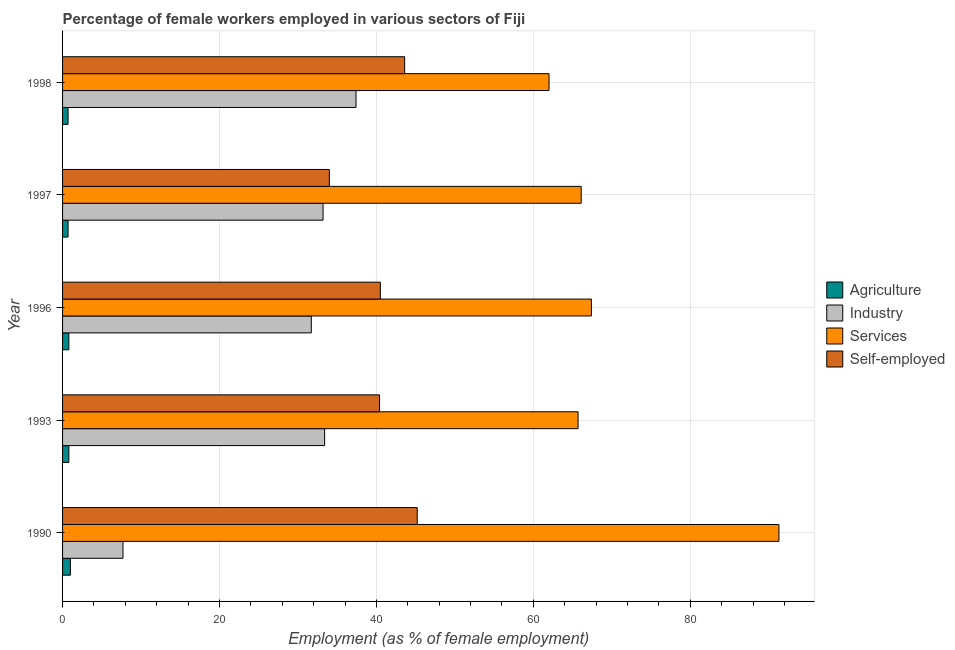How many groups of bars are there?
Make the answer very short. 5. What is the label of the 5th group of bars from the top?
Ensure brevity in your answer.  1990. In how many cases, is the number of bars for a given year not equal to the number of legend labels?
Provide a short and direct response. 0. Across all years, what is the maximum percentage of female workers in services?
Ensure brevity in your answer.  91.3. In which year was the percentage of female workers in agriculture maximum?
Provide a short and direct response. 1990. What is the total percentage of self employed female workers in the graph?
Keep it short and to the point. 203.7. What is the difference between the percentage of female workers in industry in 1990 and that in 1993?
Your answer should be very brief. -25.7. What is the difference between the percentage of self employed female workers in 1990 and the percentage of female workers in services in 1998?
Offer a terse response. -16.8. In the year 1990, what is the difference between the percentage of female workers in industry and percentage of female workers in services?
Keep it short and to the point. -83.6. What is the difference between the highest and the second highest percentage of female workers in industry?
Your response must be concise. 4. What is the difference between the highest and the lowest percentage of female workers in services?
Provide a succinct answer. 29.3. Is it the case that in every year, the sum of the percentage of female workers in services and percentage of self employed female workers is greater than the sum of percentage of female workers in industry and percentage of female workers in agriculture?
Give a very brief answer. Yes. What does the 1st bar from the top in 1990 represents?
Offer a very short reply. Self-employed. What does the 2nd bar from the bottom in 1993 represents?
Keep it short and to the point. Industry. How many bars are there?
Your answer should be compact. 20. How many years are there in the graph?
Provide a succinct answer. 5. Are the values on the major ticks of X-axis written in scientific E-notation?
Keep it short and to the point. No. Where does the legend appear in the graph?
Offer a terse response. Center right. How many legend labels are there?
Offer a terse response. 4. What is the title of the graph?
Provide a short and direct response. Percentage of female workers employed in various sectors of Fiji. Does "Labor Taxes" appear as one of the legend labels in the graph?
Your response must be concise. No. What is the label or title of the X-axis?
Your answer should be compact. Employment (as % of female employment). What is the Employment (as % of female employment) in Industry in 1990?
Offer a very short reply. 7.7. What is the Employment (as % of female employment) of Services in 1990?
Offer a very short reply. 91.3. What is the Employment (as % of female employment) of Self-employed in 1990?
Keep it short and to the point. 45.2. What is the Employment (as % of female employment) in Agriculture in 1993?
Keep it short and to the point. 0.8. What is the Employment (as % of female employment) of Industry in 1993?
Your answer should be compact. 33.4. What is the Employment (as % of female employment) in Services in 1993?
Make the answer very short. 65.7. What is the Employment (as % of female employment) in Self-employed in 1993?
Your answer should be compact. 40.4. What is the Employment (as % of female employment) in Agriculture in 1996?
Your response must be concise. 0.8. What is the Employment (as % of female employment) of Industry in 1996?
Your answer should be compact. 31.7. What is the Employment (as % of female employment) of Services in 1996?
Your answer should be compact. 67.4. What is the Employment (as % of female employment) of Self-employed in 1996?
Your answer should be compact. 40.5. What is the Employment (as % of female employment) in Agriculture in 1997?
Make the answer very short. 0.7. What is the Employment (as % of female employment) in Industry in 1997?
Your response must be concise. 33.2. What is the Employment (as % of female employment) in Services in 1997?
Offer a terse response. 66.1. What is the Employment (as % of female employment) of Agriculture in 1998?
Provide a succinct answer. 0.7. What is the Employment (as % of female employment) of Industry in 1998?
Ensure brevity in your answer.  37.4. What is the Employment (as % of female employment) in Self-employed in 1998?
Provide a short and direct response. 43.6. Across all years, what is the maximum Employment (as % of female employment) in Agriculture?
Ensure brevity in your answer.  1. Across all years, what is the maximum Employment (as % of female employment) of Industry?
Give a very brief answer. 37.4. Across all years, what is the maximum Employment (as % of female employment) in Services?
Your answer should be very brief. 91.3. Across all years, what is the maximum Employment (as % of female employment) in Self-employed?
Your answer should be very brief. 45.2. Across all years, what is the minimum Employment (as % of female employment) of Agriculture?
Keep it short and to the point. 0.7. Across all years, what is the minimum Employment (as % of female employment) of Industry?
Offer a very short reply. 7.7. What is the total Employment (as % of female employment) of Industry in the graph?
Give a very brief answer. 143.4. What is the total Employment (as % of female employment) in Services in the graph?
Your response must be concise. 352.5. What is the total Employment (as % of female employment) of Self-employed in the graph?
Give a very brief answer. 203.7. What is the difference between the Employment (as % of female employment) of Agriculture in 1990 and that in 1993?
Provide a succinct answer. 0.2. What is the difference between the Employment (as % of female employment) in Industry in 1990 and that in 1993?
Keep it short and to the point. -25.7. What is the difference between the Employment (as % of female employment) of Services in 1990 and that in 1993?
Offer a terse response. 25.6. What is the difference between the Employment (as % of female employment) of Self-employed in 1990 and that in 1993?
Your answer should be very brief. 4.8. What is the difference between the Employment (as % of female employment) in Agriculture in 1990 and that in 1996?
Give a very brief answer. 0.2. What is the difference between the Employment (as % of female employment) of Industry in 1990 and that in 1996?
Your response must be concise. -24. What is the difference between the Employment (as % of female employment) in Services in 1990 and that in 1996?
Your response must be concise. 23.9. What is the difference between the Employment (as % of female employment) in Agriculture in 1990 and that in 1997?
Make the answer very short. 0.3. What is the difference between the Employment (as % of female employment) of Industry in 1990 and that in 1997?
Provide a succinct answer. -25.5. What is the difference between the Employment (as % of female employment) in Services in 1990 and that in 1997?
Give a very brief answer. 25.2. What is the difference between the Employment (as % of female employment) of Industry in 1990 and that in 1998?
Make the answer very short. -29.7. What is the difference between the Employment (as % of female employment) of Services in 1990 and that in 1998?
Ensure brevity in your answer.  29.3. What is the difference between the Employment (as % of female employment) in Self-employed in 1990 and that in 1998?
Your response must be concise. 1.6. What is the difference between the Employment (as % of female employment) of Industry in 1993 and that in 1996?
Your answer should be very brief. 1.7. What is the difference between the Employment (as % of female employment) in Services in 1993 and that in 1996?
Your response must be concise. -1.7. What is the difference between the Employment (as % of female employment) in Self-employed in 1993 and that in 1997?
Make the answer very short. 6.4. What is the difference between the Employment (as % of female employment) of Agriculture in 1993 and that in 1998?
Keep it short and to the point. 0.1. What is the difference between the Employment (as % of female employment) of Industry in 1993 and that in 1998?
Keep it short and to the point. -4. What is the difference between the Employment (as % of female employment) in Industry in 1996 and that in 1997?
Offer a terse response. -1.5. What is the difference between the Employment (as % of female employment) in Self-employed in 1996 and that in 1997?
Your answer should be compact. 6.5. What is the difference between the Employment (as % of female employment) in Agriculture in 1996 and that in 1998?
Your response must be concise. 0.1. What is the difference between the Employment (as % of female employment) in Industry in 1996 and that in 1998?
Provide a succinct answer. -5.7. What is the difference between the Employment (as % of female employment) in Services in 1996 and that in 1998?
Ensure brevity in your answer.  5.4. What is the difference between the Employment (as % of female employment) of Agriculture in 1997 and that in 1998?
Ensure brevity in your answer.  0. What is the difference between the Employment (as % of female employment) of Agriculture in 1990 and the Employment (as % of female employment) of Industry in 1993?
Make the answer very short. -32.4. What is the difference between the Employment (as % of female employment) in Agriculture in 1990 and the Employment (as % of female employment) in Services in 1993?
Your answer should be very brief. -64.7. What is the difference between the Employment (as % of female employment) in Agriculture in 1990 and the Employment (as % of female employment) in Self-employed in 1993?
Provide a succinct answer. -39.4. What is the difference between the Employment (as % of female employment) of Industry in 1990 and the Employment (as % of female employment) of Services in 1993?
Keep it short and to the point. -58. What is the difference between the Employment (as % of female employment) of Industry in 1990 and the Employment (as % of female employment) of Self-employed in 1993?
Provide a short and direct response. -32.7. What is the difference between the Employment (as % of female employment) of Services in 1990 and the Employment (as % of female employment) of Self-employed in 1993?
Ensure brevity in your answer.  50.9. What is the difference between the Employment (as % of female employment) in Agriculture in 1990 and the Employment (as % of female employment) in Industry in 1996?
Ensure brevity in your answer.  -30.7. What is the difference between the Employment (as % of female employment) in Agriculture in 1990 and the Employment (as % of female employment) in Services in 1996?
Offer a terse response. -66.4. What is the difference between the Employment (as % of female employment) in Agriculture in 1990 and the Employment (as % of female employment) in Self-employed in 1996?
Provide a succinct answer. -39.5. What is the difference between the Employment (as % of female employment) of Industry in 1990 and the Employment (as % of female employment) of Services in 1996?
Offer a terse response. -59.7. What is the difference between the Employment (as % of female employment) in Industry in 1990 and the Employment (as % of female employment) in Self-employed in 1996?
Your answer should be very brief. -32.8. What is the difference between the Employment (as % of female employment) in Services in 1990 and the Employment (as % of female employment) in Self-employed in 1996?
Provide a short and direct response. 50.8. What is the difference between the Employment (as % of female employment) of Agriculture in 1990 and the Employment (as % of female employment) of Industry in 1997?
Keep it short and to the point. -32.2. What is the difference between the Employment (as % of female employment) of Agriculture in 1990 and the Employment (as % of female employment) of Services in 1997?
Your answer should be compact. -65.1. What is the difference between the Employment (as % of female employment) of Agriculture in 1990 and the Employment (as % of female employment) of Self-employed in 1997?
Offer a terse response. -33. What is the difference between the Employment (as % of female employment) in Industry in 1990 and the Employment (as % of female employment) in Services in 1997?
Your response must be concise. -58.4. What is the difference between the Employment (as % of female employment) in Industry in 1990 and the Employment (as % of female employment) in Self-employed in 1997?
Your answer should be compact. -26.3. What is the difference between the Employment (as % of female employment) in Services in 1990 and the Employment (as % of female employment) in Self-employed in 1997?
Your response must be concise. 57.3. What is the difference between the Employment (as % of female employment) of Agriculture in 1990 and the Employment (as % of female employment) of Industry in 1998?
Your answer should be compact. -36.4. What is the difference between the Employment (as % of female employment) of Agriculture in 1990 and the Employment (as % of female employment) of Services in 1998?
Your answer should be very brief. -61. What is the difference between the Employment (as % of female employment) of Agriculture in 1990 and the Employment (as % of female employment) of Self-employed in 1998?
Your response must be concise. -42.6. What is the difference between the Employment (as % of female employment) of Industry in 1990 and the Employment (as % of female employment) of Services in 1998?
Provide a short and direct response. -54.3. What is the difference between the Employment (as % of female employment) in Industry in 1990 and the Employment (as % of female employment) in Self-employed in 1998?
Make the answer very short. -35.9. What is the difference between the Employment (as % of female employment) in Services in 1990 and the Employment (as % of female employment) in Self-employed in 1998?
Provide a short and direct response. 47.7. What is the difference between the Employment (as % of female employment) of Agriculture in 1993 and the Employment (as % of female employment) of Industry in 1996?
Provide a short and direct response. -30.9. What is the difference between the Employment (as % of female employment) in Agriculture in 1993 and the Employment (as % of female employment) in Services in 1996?
Keep it short and to the point. -66.6. What is the difference between the Employment (as % of female employment) of Agriculture in 1993 and the Employment (as % of female employment) of Self-employed in 1996?
Offer a very short reply. -39.7. What is the difference between the Employment (as % of female employment) of Industry in 1993 and the Employment (as % of female employment) of Services in 1996?
Your answer should be compact. -34. What is the difference between the Employment (as % of female employment) of Industry in 1993 and the Employment (as % of female employment) of Self-employed in 1996?
Your response must be concise. -7.1. What is the difference between the Employment (as % of female employment) of Services in 1993 and the Employment (as % of female employment) of Self-employed in 1996?
Your answer should be compact. 25.2. What is the difference between the Employment (as % of female employment) in Agriculture in 1993 and the Employment (as % of female employment) in Industry in 1997?
Offer a very short reply. -32.4. What is the difference between the Employment (as % of female employment) in Agriculture in 1993 and the Employment (as % of female employment) in Services in 1997?
Ensure brevity in your answer.  -65.3. What is the difference between the Employment (as % of female employment) of Agriculture in 1993 and the Employment (as % of female employment) of Self-employed in 1997?
Your answer should be very brief. -33.2. What is the difference between the Employment (as % of female employment) in Industry in 1993 and the Employment (as % of female employment) in Services in 1997?
Make the answer very short. -32.7. What is the difference between the Employment (as % of female employment) of Services in 1993 and the Employment (as % of female employment) of Self-employed in 1997?
Your answer should be compact. 31.7. What is the difference between the Employment (as % of female employment) in Agriculture in 1993 and the Employment (as % of female employment) in Industry in 1998?
Give a very brief answer. -36.6. What is the difference between the Employment (as % of female employment) of Agriculture in 1993 and the Employment (as % of female employment) of Services in 1998?
Give a very brief answer. -61.2. What is the difference between the Employment (as % of female employment) of Agriculture in 1993 and the Employment (as % of female employment) of Self-employed in 1998?
Make the answer very short. -42.8. What is the difference between the Employment (as % of female employment) of Industry in 1993 and the Employment (as % of female employment) of Services in 1998?
Offer a very short reply. -28.6. What is the difference between the Employment (as % of female employment) of Services in 1993 and the Employment (as % of female employment) of Self-employed in 1998?
Make the answer very short. 22.1. What is the difference between the Employment (as % of female employment) in Agriculture in 1996 and the Employment (as % of female employment) in Industry in 1997?
Your response must be concise. -32.4. What is the difference between the Employment (as % of female employment) in Agriculture in 1996 and the Employment (as % of female employment) in Services in 1997?
Provide a short and direct response. -65.3. What is the difference between the Employment (as % of female employment) in Agriculture in 1996 and the Employment (as % of female employment) in Self-employed in 1997?
Offer a very short reply. -33.2. What is the difference between the Employment (as % of female employment) in Industry in 1996 and the Employment (as % of female employment) in Services in 1997?
Your answer should be compact. -34.4. What is the difference between the Employment (as % of female employment) of Services in 1996 and the Employment (as % of female employment) of Self-employed in 1997?
Make the answer very short. 33.4. What is the difference between the Employment (as % of female employment) in Agriculture in 1996 and the Employment (as % of female employment) in Industry in 1998?
Your answer should be very brief. -36.6. What is the difference between the Employment (as % of female employment) of Agriculture in 1996 and the Employment (as % of female employment) of Services in 1998?
Keep it short and to the point. -61.2. What is the difference between the Employment (as % of female employment) of Agriculture in 1996 and the Employment (as % of female employment) of Self-employed in 1998?
Give a very brief answer. -42.8. What is the difference between the Employment (as % of female employment) of Industry in 1996 and the Employment (as % of female employment) of Services in 1998?
Your answer should be very brief. -30.3. What is the difference between the Employment (as % of female employment) in Industry in 1996 and the Employment (as % of female employment) in Self-employed in 1998?
Make the answer very short. -11.9. What is the difference between the Employment (as % of female employment) of Services in 1996 and the Employment (as % of female employment) of Self-employed in 1998?
Your answer should be compact. 23.8. What is the difference between the Employment (as % of female employment) in Agriculture in 1997 and the Employment (as % of female employment) in Industry in 1998?
Ensure brevity in your answer.  -36.7. What is the difference between the Employment (as % of female employment) of Agriculture in 1997 and the Employment (as % of female employment) of Services in 1998?
Give a very brief answer. -61.3. What is the difference between the Employment (as % of female employment) in Agriculture in 1997 and the Employment (as % of female employment) in Self-employed in 1998?
Provide a short and direct response. -42.9. What is the difference between the Employment (as % of female employment) of Industry in 1997 and the Employment (as % of female employment) of Services in 1998?
Offer a terse response. -28.8. What is the difference between the Employment (as % of female employment) of Industry in 1997 and the Employment (as % of female employment) of Self-employed in 1998?
Make the answer very short. -10.4. What is the difference between the Employment (as % of female employment) of Services in 1997 and the Employment (as % of female employment) of Self-employed in 1998?
Your response must be concise. 22.5. What is the average Employment (as % of female employment) of Agriculture per year?
Give a very brief answer. 0.8. What is the average Employment (as % of female employment) of Industry per year?
Offer a terse response. 28.68. What is the average Employment (as % of female employment) in Services per year?
Provide a short and direct response. 70.5. What is the average Employment (as % of female employment) of Self-employed per year?
Provide a short and direct response. 40.74. In the year 1990, what is the difference between the Employment (as % of female employment) of Agriculture and Employment (as % of female employment) of Services?
Provide a short and direct response. -90.3. In the year 1990, what is the difference between the Employment (as % of female employment) of Agriculture and Employment (as % of female employment) of Self-employed?
Your response must be concise. -44.2. In the year 1990, what is the difference between the Employment (as % of female employment) of Industry and Employment (as % of female employment) of Services?
Offer a terse response. -83.6. In the year 1990, what is the difference between the Employment (as % of female employment) of Industry and Employment (as % of female employment) of Self-employed?
Offer a very short reply. -37.5. In the year 1990, what is the difference between the Employment (as % of female employment) in Services and Employment (as % of female employment) in Self-employed?
Offer a very short reply. 46.1. In the year 1993, what is the difference between the Employment (as % of female employment) in Agriculture and Employment (as % of female employment) in Industry?
Keep it short and to the point. -32.6. In the year 1993, what is the difference between the Employment (as % of female employment) of Agriculture and Employment (as % of female employment) of Services?
Make the answer very short. -64.9. In the year 1993, what is the difference between the Employment (as % of female employment) in Agriculture and Employment (as % of female employment) in Self-employed?
Give a very brief answer. -39.6. In the year 1993, what is the difference between the Employment (as % of female employment) of Industry and Employment (as % of female employment) of Services?
Your answer should be very brief. -32.3. In the year 1993, what is the difference between the Employment (as % of female employment) of Services and Employment (as % of female employment) of Self-employed?
Provide a succinct answer. 25.3. In the year 1996, what is the difference between the Employment (as % of female employment) in Agriculture and Employment (as % of female employment) in Industry?
Provide a short and direct response. -30.9. In the year 1996, what is the difference between the Employment (as % of female employment) in Agriculture and Employment (as % of female employment) in Services?
Keep it short and to the point. -66.6. In the year 1996, what is the difference between the Employment (as % of female employment) in Agriculture and Employment (as % of female employment) in Self-employed?
Your answer should be very brief. -39.7. In the year 1996, what is the difference between the Employment (as % of female employment) of Industry and Employment (as % of female employment) of Services?
Provide a succinct answer. -35.7. In the year 1996, what is the difference between the Employment (as % of female employment) in Services and Employment (as % of female employment) in Self-employed?
Ensure brevity in your answer.  26.9. In the year 1997, what is the difference between the Employment (as % of female employment) of Agriculture and Employment (as % of female employment) of Industry?
Your response must be concise. -32.5. In the year 1997, what is the difference between the Employment (as % of female employment) in Agriculture and Employment (as % of female employment) in Services?
Give a very brief answer. -65.4. In the year 1997, what is the difference between the Employment (as % of female employment) in Agriculture and Employment (as % of female employment) in Self-employed?
Your response must be concise. -33.3. In the year 1997, what is the difference between the Employment (as % of female employment) of Industry and Employment (as % of female employment) of Services?
Offer a very short reply. -32.9. In the year 1997, what is the difference between the Employment (as % of female employment) in Services and Employment (as % of female employment) in Self-employed?
Provide a short and direct response. 32.1. In the year 1998, what is the difference between the Employment (as % of female employment) of Agriculture and Employment (as % of female employment) of Industry?
Ensure brevity in your answer.  -36.7. In the year 1998, what is the difference between the Employment (as % of female employment) in Agriculture and Employment (as % of female employment) in Services?
Ensure brevity in your answer.  -61.3. In the year 1998, what is the difference between the Employment (as % of female employment) in Agriculture and Employment (as % of female employment) in Self-employed?
Your answer should be compact. -42.9. In the year 1998, what is the difference between the Employment (as % of female employment) of Industry and Employment (as % of female employment) of Services?
Your response must be concise. -24.6. In the year 1998, what is the difference between the Employment (as % of female employment) of Services and Employment (as % of female employment) of Self-employed?
Offer a terse response. 18.4. What is the ratio of the Employment (as % of female employment) of Agriculture in 1990 to that in 1993?
Your answer should be compact. 1.25. What is the ratio of the Employment (as % of female employment) in Industry in 1990 to that in 1993?
Your answer should be very brief. 0.23. What is the ratio of the Employment (as % of female employment) of Services in 1990 to that in 1993?
Ensure brevity in your answer.  1.39. What is the ratio of the Employment (as % of female employment) of Self-employed in 1990 to that in 1993?
Your answer should be very brief. 1.12. What is the ratio of the Employment (as % of female employment) in Industry in 1990 to that in 1996?
Offer a very short reply. 0.24. What is the ratio of the Employment (as % of female employment) in Services in 1990 to that in 1996?
Offer a very short reply. 1.35. What is the ratio of the Employment (as % of female employment) of Self-employed in 1990 to that in 1996?
Your answer should be very brief. 1.12. What is the ratio of the Employment (as % of female employment) in Agriculture in 1990 to that in 1997?
Your response must be concise. 1.43. What is the ratio of the Employment (as % of female employment) in Industry in 1990 to that in 1997?
Your answer should be compact. 0.23. What is the ratio of the Employment (as % of female employment) of Services in 1990 to that in 1997?
Offer a very short reply. 1.38. What is the ratio of the Employment (as % of female employment) in Self-employed in 1990 to that in 1997?
Ensure brevity in your answer.  1.33. What is the ratio of the Employment (as % of female employment) in Agriculture in 1990 to that in 1998?
Your answer should be compact. 1.43. What is the ratio of the Employment (as % of female employment) of Industry in 1990 to that in 1998?
Offer a very short reply. 0.21. What is the ratio of the Employment (as % of female employment) of Services in 1990 to that in 1998?
Keep it short and to the point. 1.47. What is the ratio of the Employment (as % of female employment) in Self-employed in 1990 to that in 1998?
Provide a succinct answer. 1.04. What is the ratio of the Employment (as % of female employment) in Industry in 1993 to that in 1996?
Ensure brevity in your answer.  1.05. What is the ratio of the Employment (as % of female employment) of Services in 1993 to that in 1996?
Provide a short and direct response. 0.97. What is the ratio of the Employment (as % of female employment) of Self-employed in 1993 to that in 1996?
Offer a very short reply. 1. What is the ratio of the Employment (as % of female employment) of Industry in 1993 to that in 1997?
Make the answer very short. 1.01. What is the ratio of the Employment (as % of female employment) of Self-employed in 1993 to that in 1997?
Keep it short and to the point. 1.19. What is the ratio of the Employment (as % of female employment) in Agriculture in 1993 to that in 1998?
Offer a very short reply. 1.14. What is the ratio of the Employment (as % of female employment) in Industry in 1993 to that in 1998?
Ensure brevity in your answer.  0.89. What is the ratio of the Employment (as % of female employment) of Services in 1993 to that in 1998?
Make the answer very short. 1.06. What is the ratio of the Employment (as % of female employment) in Self-employed in 1993 to that in 1998?
Offer a very short reply. 0.93. What is the ratio of the Employment (as % of female employment) in Industry in 1996 to that in 1997?
Your response must be concise. 0.95. What is the ratio of the Employment (as % of female employment) in Services in 1996 to that in 1997?
Offer a very short reply. 1.02. What is the ratio of the Employment (as % of female employment) of Self-employed in 1996 to that in 1997?
Offer a terse response. 1.19. What is the ratio of the Employment (as % of female employment) of Agriculture in 1996 to that in 1998?
Your answer should be very brief. 1.14. What is the ratio of the Employment (as % of female employment) in Industry in 1996 to that in 1998?
Provide a succinct answer. 0.85. What is the ratio of the Employment (as % of female employment) in Services in 1996 to that in 1998?
Give a very brief answer. 1.09. What is the ratio of the Employment (as % of female employment) in Self-employed in 1996 to that in 1998?
Offer a very short reply. 0.93. What is the ratio of the Employment (as % of female employment) of Industry in 1997 to that in 1998?
Your response must be concise. 0.89. What is the ratio of the Employment (as % of female employment) of Services in 1997 to that in 1998?
Keep it short and to the point. 1.07. What is the ratio of the Employment (as % of female employment) in Self-employed in 1997 to that in 1998?
Provide a succinct answer. 0.78. What is the difference between the highest and the second highest Employment (as % of female employment) in Agriculture?
Ensure brevity in your answer.  0.2. What is the difference between the highest and the second highest Employment (as % of female employment) in Services?
Offer a terse response. 23.9. What is the difference between the highest and the second highest Employment (as % of female employment) of Self-employed?
Provide a short and direct response. 1.6. What is the difference between the highest and the lowest Employment (as % of female employment) of Agriculture?
Ensure brevity in your answer.  0.3. What is the difference between the highest and the lowest Employment (as % of female employment) of Industry?
Your answer should be compact. 29.7. What is the difference between the highest and the lowest Employment (as % of female employment) of Services?
Make the answer very short. 29.3. 